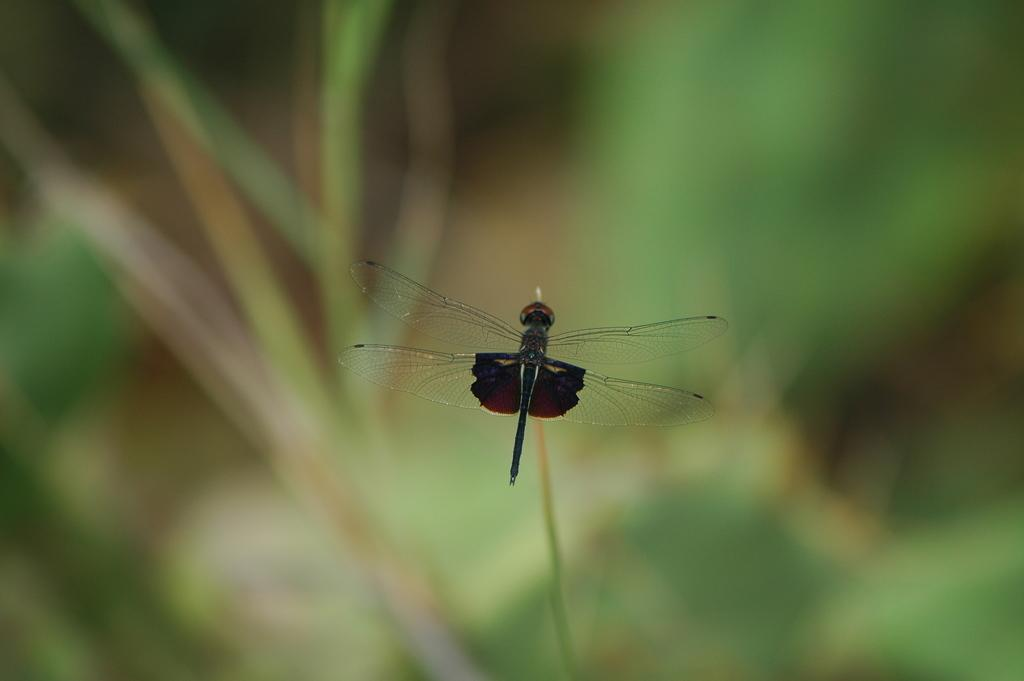What is the main subject of the picture? The main subject of the picture is a dragonfly. Where is the dragonfly located in the image? The dragonfly is on a stem in the image. Can you describe the background of the image? The background of the image is blurred. What type of carriage can be seen in the bedroom in the image? There is no carriage or bedroom present in the image; it features a dragonfly on a stem with a blurred background. 